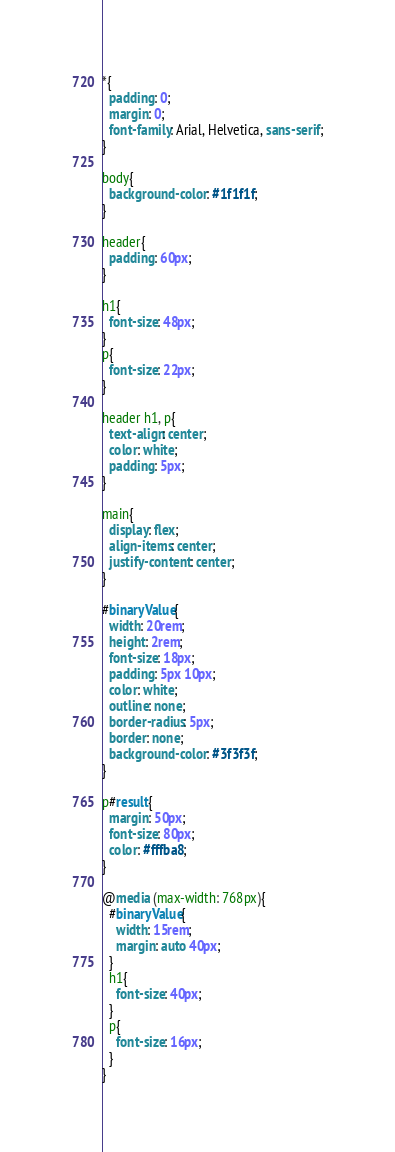Convert code to text. <code><loc_0><loc_0><loc_500><loc_500><_CSS_>*{
  padding: 0;
  margin: 0;
  font-family: Arial, Helvetica, sans-serif;
}

body{
  background-color: #1f1f1f;
}

header{
  padding: 60px;
}

h1{
  font-size: 48px;
}
p{
  font-size: 22px;
}

header h1, p{
  text-align: center;
  color: white;
  padding: 5px;
}

main{
  display: flex;
  align-items: center;
  justify-content: center;
}

#binaryValue{
  width: 20rem;
  height: 2rem;
  font-size: 18px;
  padding: 5px 10px;
  color: white;
  outline: none;
  border-radius: 5px;
  border: none;
  background-color: #3f3f3f;
}

p#result{
  margin: 50px;
  font-size: 80px;
  color: #fffba8;
}

@media (max-width: 768px){
  #binaryValue{
    width: 15rem;
    margin: auto 40px;
  }
  h1{
    font-size: 40px;
  }
  p{
    font-size: 16px;
  }
}</code> 